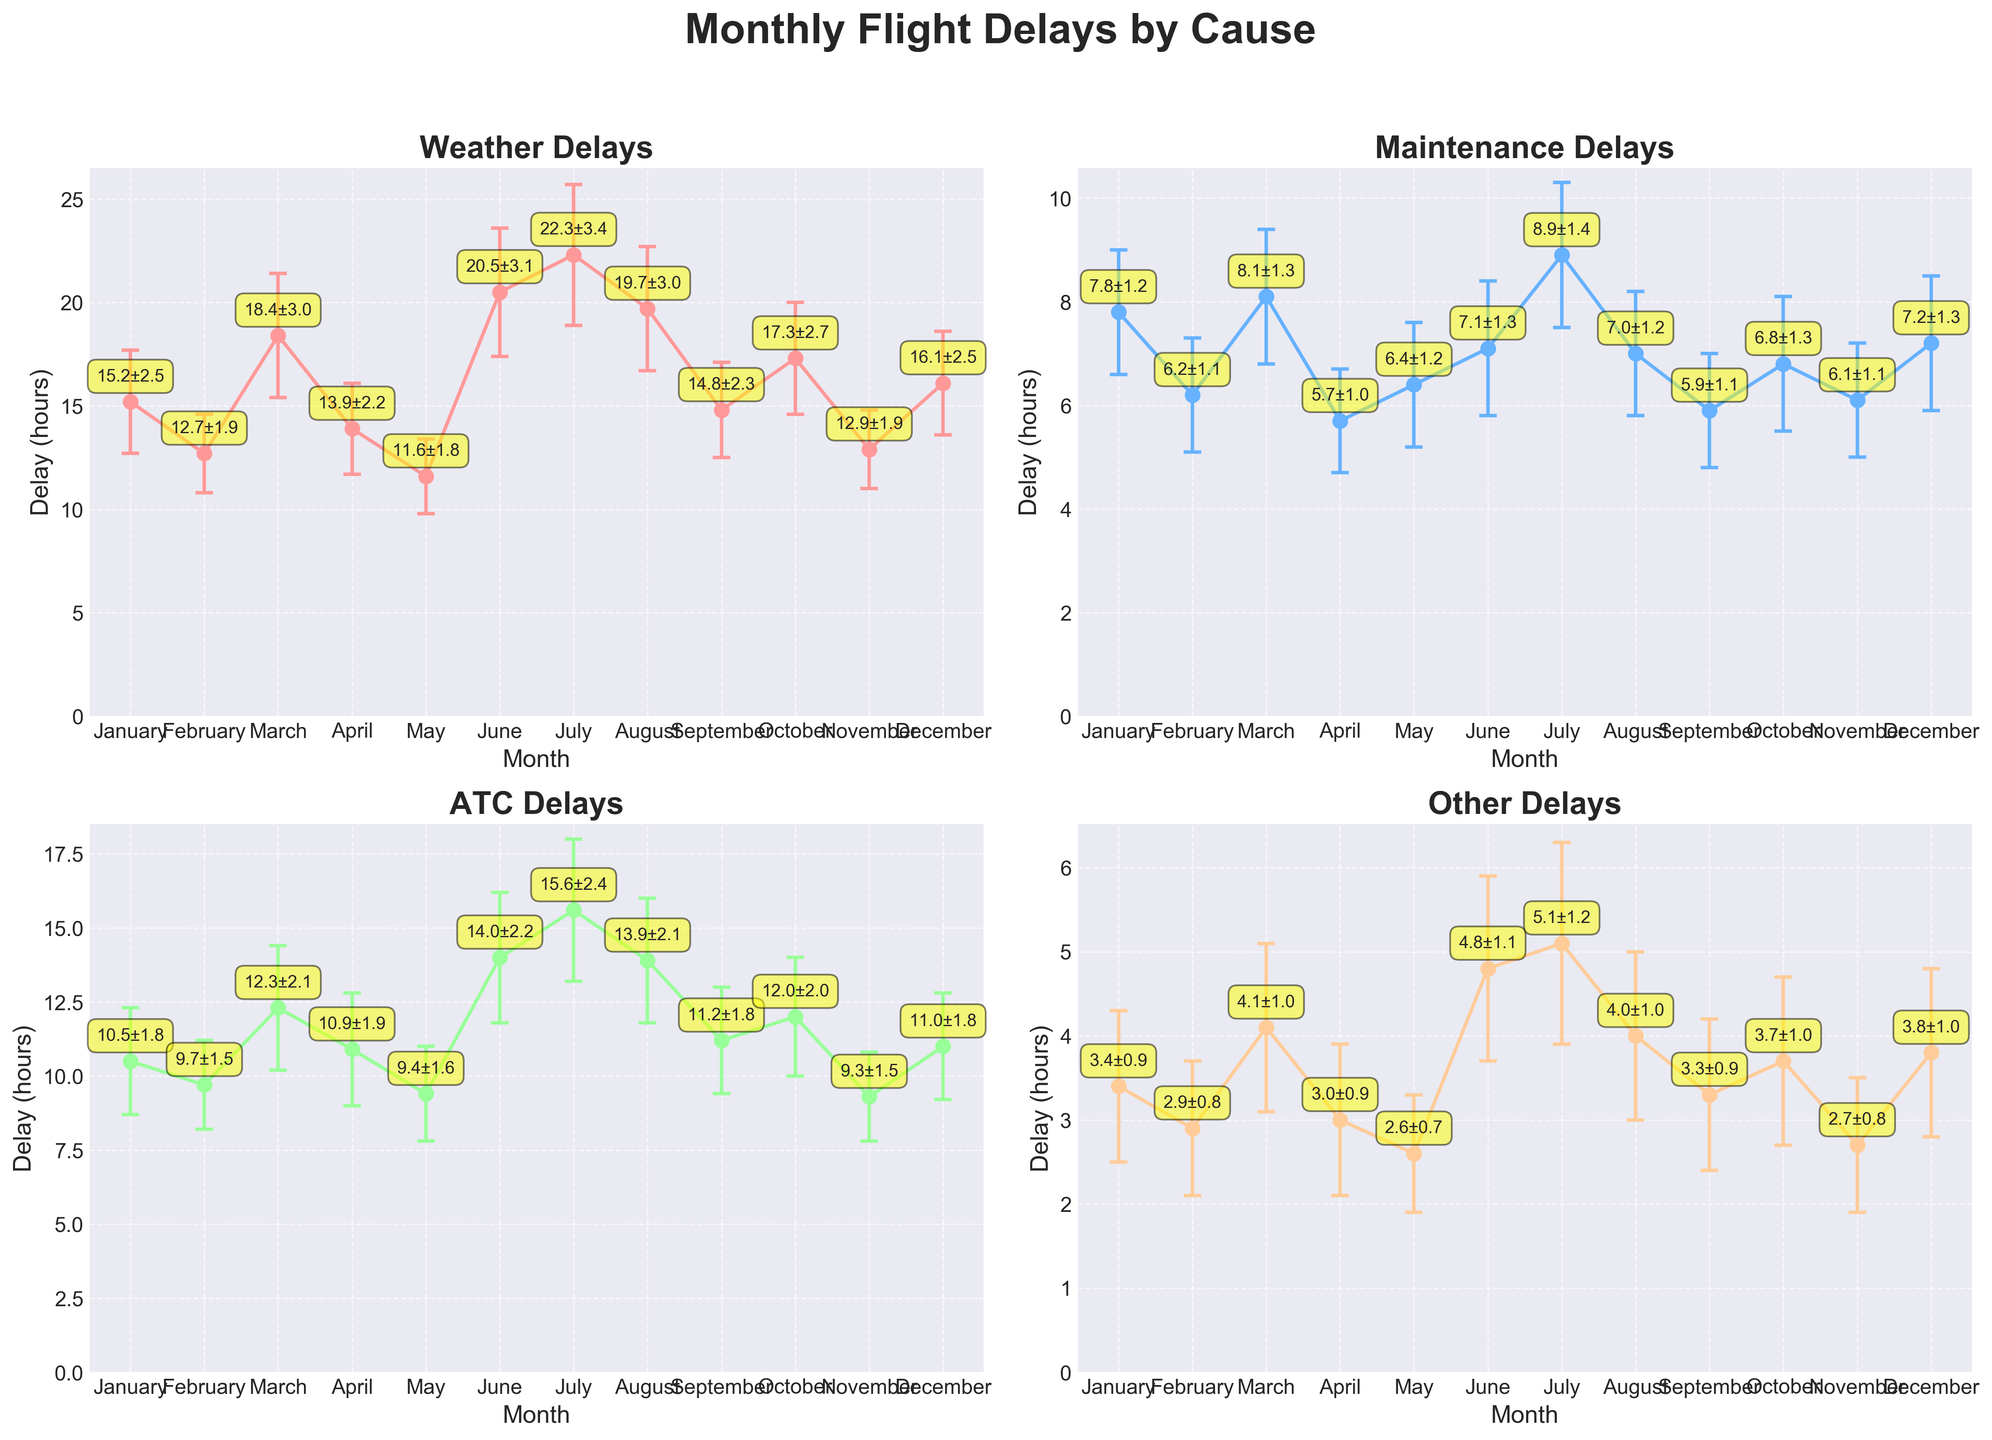How many subplots are there in the figure? There are four subplots in the figure, indicated by the distinct categories being considered: Weather Delays, Maintenance Delays, ATC Delays, and Other Delays, each displayed in a separate subplot within the 2x2 grid.
Answer: 4 What month had the highest weather delays? By looking at the subplot titled 'Weather Delays', it can be seen that July had the highest weather delay value, which is visually the highest point on the plot.
Answer: July In which month were maintenance delays the most consistent (lowest standard deviation)? In the subplot titled 'Maintenance Delays', the lowest standard deviation can be inferred from the smallest error bar. Visually, February's error bars are the smallest, indicating the most consistent delays.
Answer: February What is the sum of ATC delays in June and July? To find the sum of ATC delays in June and July, refer to the subplot titled 'ATC Delays'. June has an ATC delay of 14.0 hours and July has an ATC delay of 15.6 hours. Summing them up: 14.0 + 15.6 = 29.6 hours.
Answer: 29.6 hours Which category had the lowest average delay over the year? To identify the category with the lowest average delay, calculate the mean value of delays for each category. Summing up the delays: 
Weather: (15.2+12.7+18.4+13.9+11.6+20.5+22.3+19.7+14.8+17.3+12.9+16.1)/12 = 16.325, 
Maintenance: (7.8+6.2+8.1+5.7+6.4+7.1+8.9+7.0+5.9+6.8+6.1+7.2)/12 = 6.8167, 
ATC: (10.5+9.7+12.3+10.9+9.4+14.0+15.6+13.9+11.2+12.0+9.3+11.0)/12 = 11.6167, 
Other: (3.4+2.9+4.1+3.0+2.6+4.8+5.1+4.0+3.3+3.7+2.7+3.8)/12 = 3.5667. 
So, the order from lowest to highest average delay is: Other, Maintenance, ATC, Weather.
Answer: Other Delays How much higher were the July weather delays compared to February weather delays? To find the difference between the July and February weather delays, identify the values from the 'Weather Delays' subplot. July has 22.3 hours of weather delays, and February has 12.7 hours. The difference is: 22.3 - 12.7 = 9.6 hours.
Answer: 9.6 hours Which month had more consistent (lower standard deviation) weather delays, January or March? Comparing the weather delay errors in the 'Weather Delays' subplot, January has a standard deviation of 2.5 and March has a standard deviation of 3.0. Thus, January has the lower standard deviation.
Answer: January In which month did 'Other Delays' have the highest variability (highest standard deviation)? By checking the error bars in the 'Other Delays' subplot, the month with the largest error bar corresponds to the highest standard deviation. June has the highest variability with a standard deviation of 1.1.
Answer: June Compare the variability of ATC delays in June and December. Which month is more consistent? The subplot 'ATC Delays' shows the error bars representing variability. June has a standard deviation of 2.2 and December has a standard deviation of 1.8. Therefore, December is more consistent.
Answer: December 